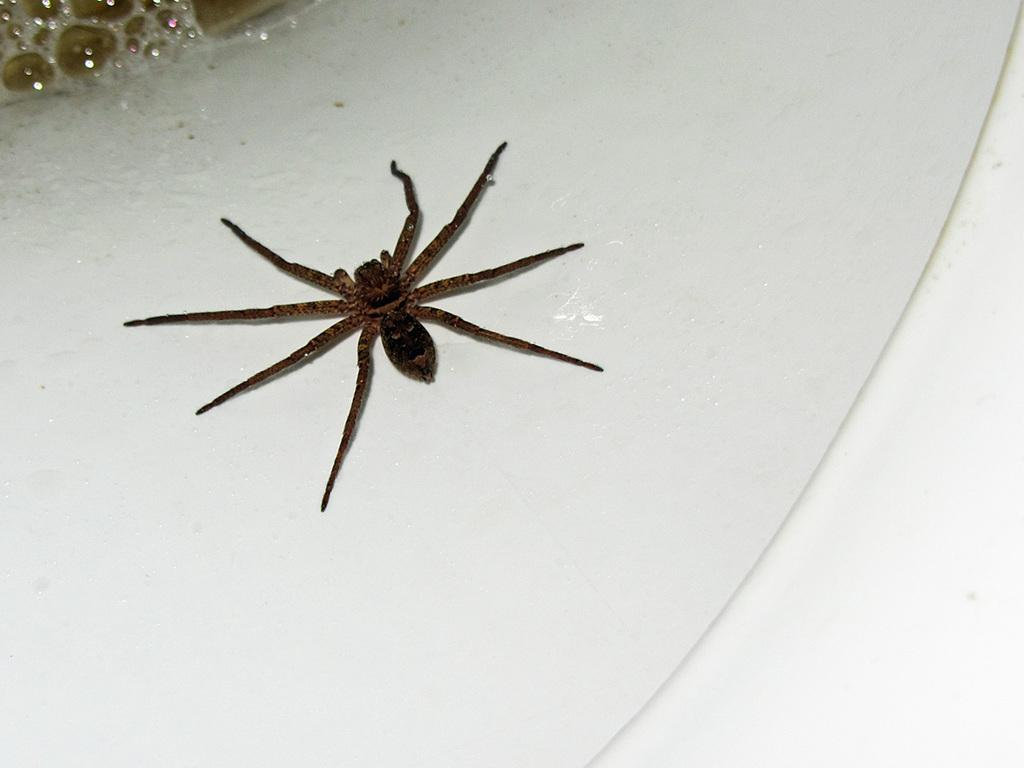What can be seen in the image that is typically found in a kitchen or bathroom? There is a sink in the image. What is present on the sink in the image? There is a spider on the sink. How many cups are visible on the sink in the image? There is no mention of cups in the image; only a sink and a spider are present. What type of ray is visible in the bedroom in the image? There is no bedroom or ray present in the image; it only features a sink and a spider. 